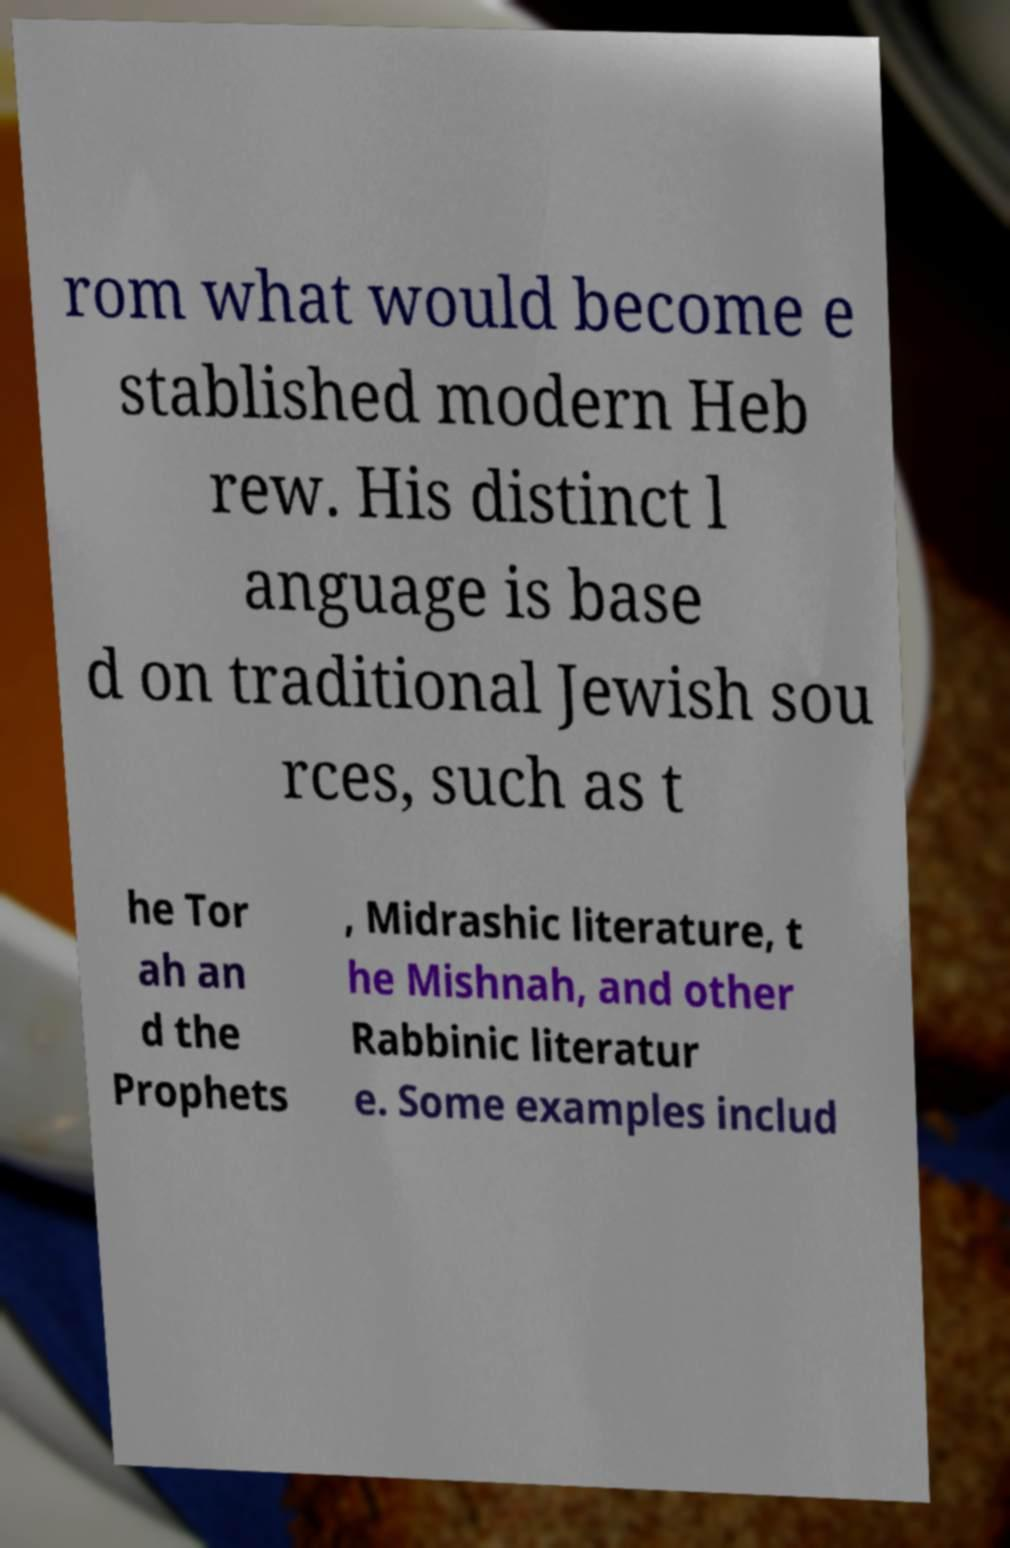Could you extract and type out the text from this image? rom what would become e stablished modern Heb rew. His distinct l anguage is base d on traditional Jewish sou rces, such as t he Tor ah an d the Prophets , Midrashic literature, t he Mishnah, and other Rabbinic literatur e. Some examples includ 